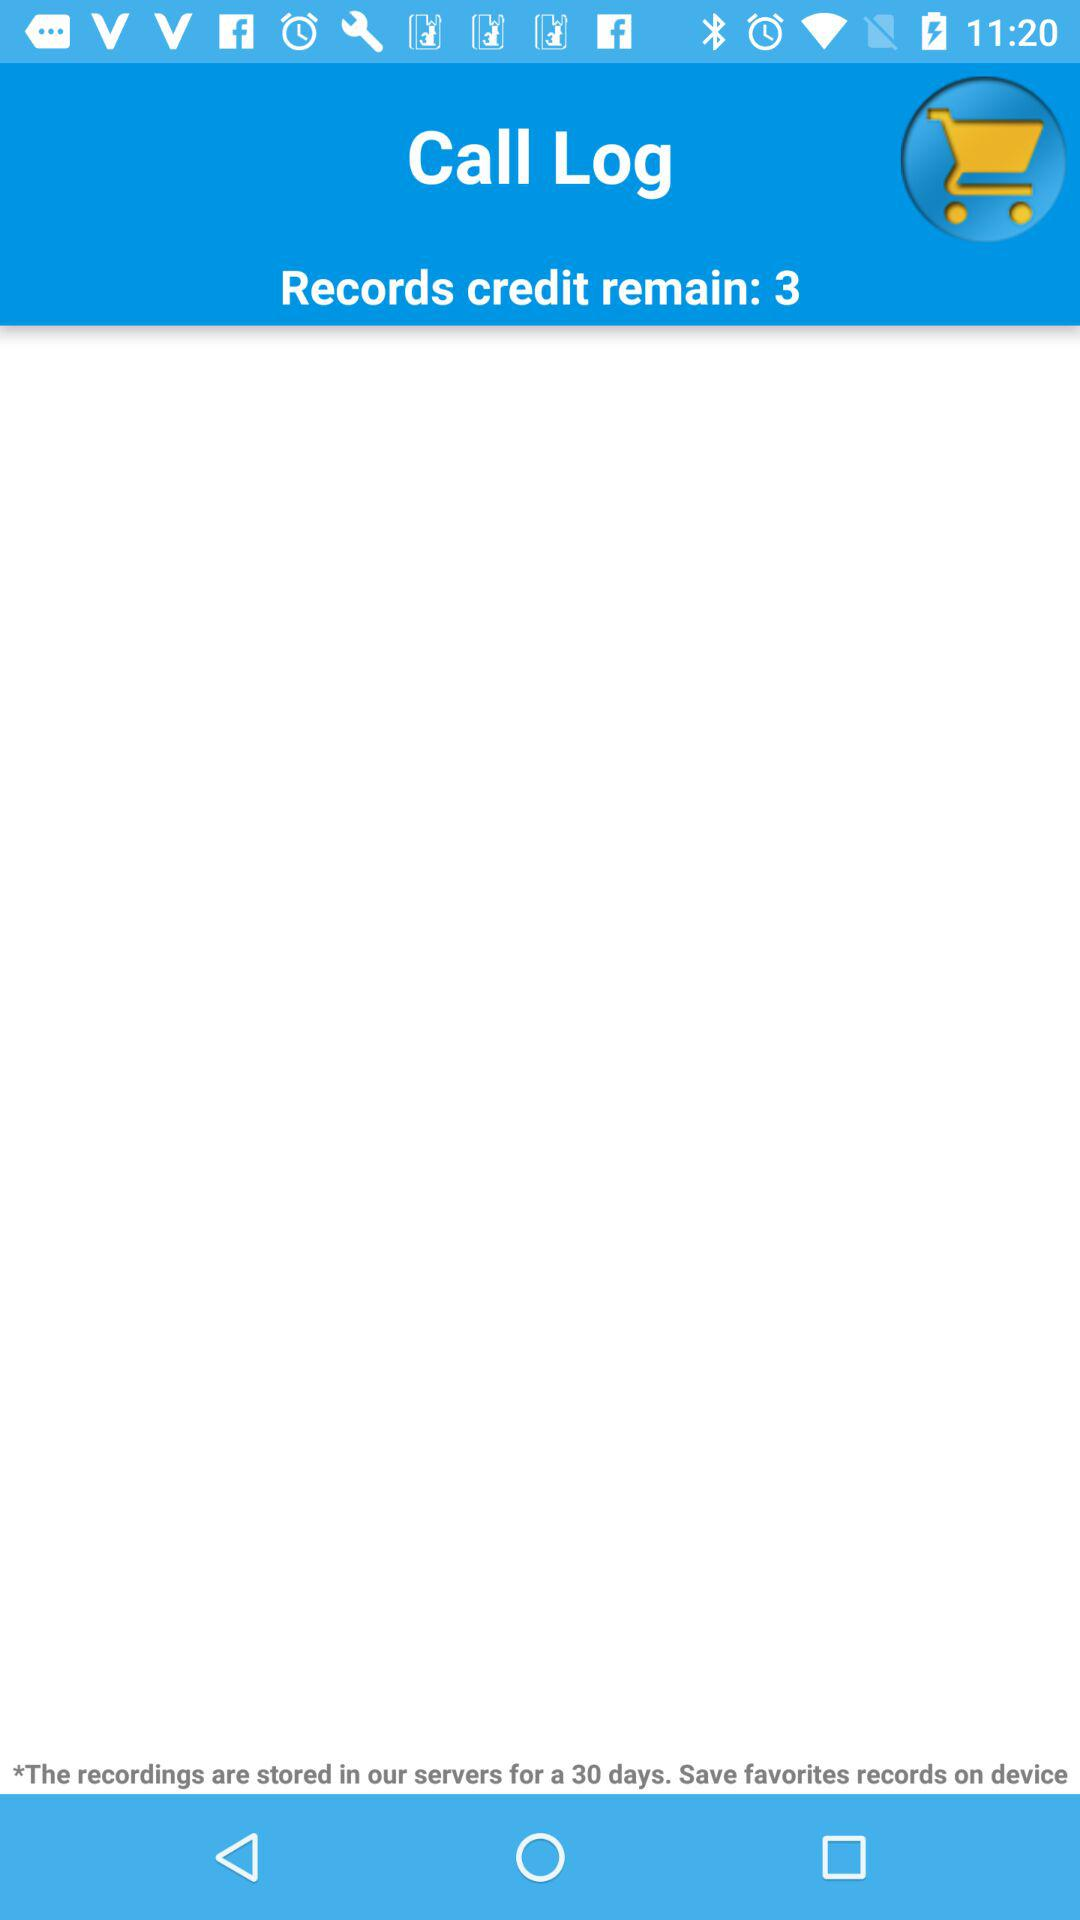What's the application name? The application name is "Call Log". 